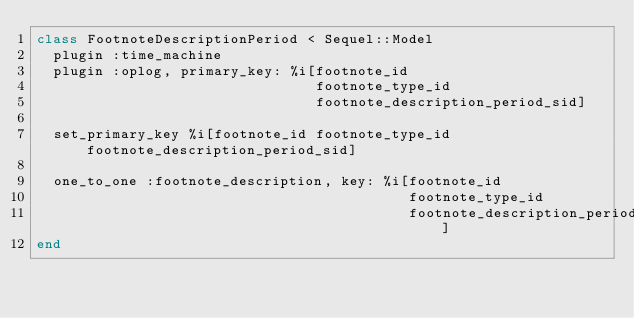<code> <loc_0><loc_0><loc_500><loc_500><_Ruby_>class FootnoteDescriptionPeriod < Sequel::Model
  plugin :time_machine
  plugin :oplog, primary_key: %i[footnote_id
                                 footnote_type_id
                                 footnote_description_period_sid]

  set_primary_key %i[footnote_id footnote_type_id footnote_description_period_sid]

  one_to_one :footnote_description, key: %i[footnote_id
                                            footnote_type_id
                                            footnote_description_period_sid]
end
</code> 